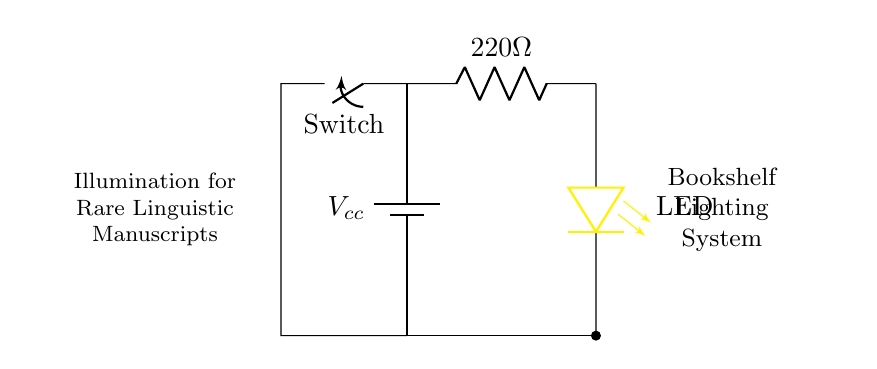What is the voltage provided by the battery? The circuit shows a battery labeled Vcc, which typically indicates the voltage supplied can vary depending on the battery size, but in common configurations, it could be 9V.
Answer: Vcc What is the resistance value of the current limiting resistor? The resistor in the circuit is labeled as 220 ohms, indicating that this is the resistance that will limit the current flowing to the LED.
Answer: 220 ohms What type of light source is used in this circuit? The circuit diagram includes a component labeled LED, which stands for Light Emitting Diode, indicating this is the light source used for illumination.
Answer: LED How many components are connected in series in this circuit? The circuit contains one battery, one resistor, one LED, and a switch connected in sequence; thus, there are four components arranged in series.
Answer: Four What role does the resistor play in this LED circuit? The resistor limits the current flowing to the LED to prevent it from drawing too much current, which could damage it. This is essential in LED circuits to ensure longevity and proper operation.
Answer: Current limiting What happens when the switch is open in this circuit? An open switch in this circuit creates a complete break in the circuit path, which stops current flow and turns off the LED, preventing it from lighting up.
Answer: LED off What type of circuit does this diagram represent? This circuit is classified as a basic LED circuit designed specifically for lighting purposes, aimed at providing illumination for rare manuscripts on a bookshelf.
Answer: Basic LED circuit 